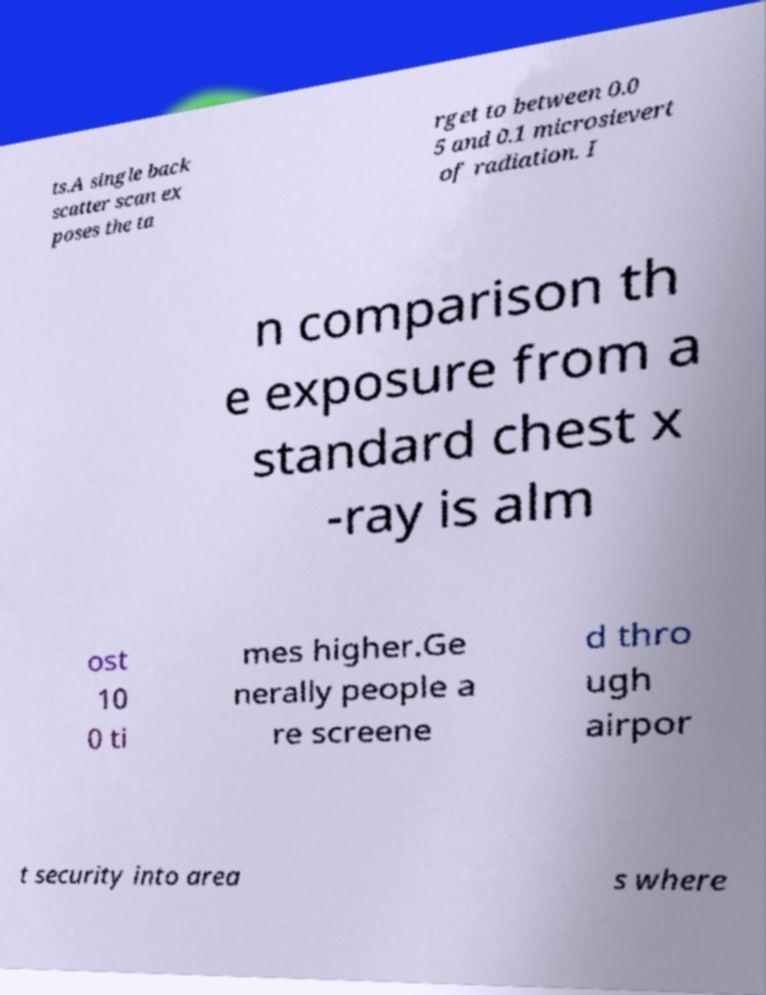Can you read and provide the text displayed in the image?This photo seems to have some interesting text. Can you extract and type it out for me? ts.A single back scatter scan ex poses the ta rget to between 0.0 5 and 0.1 microsievert of radiation. I n comparison th e exposure from a standard chest x -ray is alm ost 10 0 ti mes higher.Ge nerally people a re screene d thro ugh airpor t security into area s where 